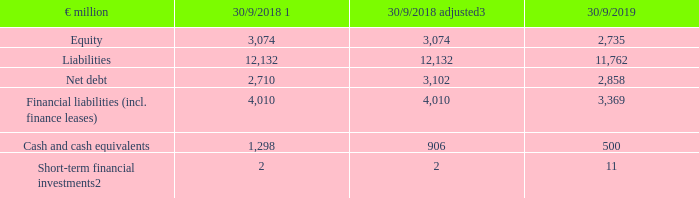Equity, liabilities and net debt in the consolidated financial statements
Equity amounts to €2,735 million (30/9/2018: €3,074 million), while liabilities amounts to €11,762 million (30/9/2018: €12,132 million). Net debt related to continuing operations decreased by €0.2 billion in the adjusted year-on-year comparison and amounted to €2.9 billion as of 30 September 2019 (30/09/2018: €3.1 billion).
1 Adjustment of previous year according to explanation in notes
2 Shown in the balance sheet under other financial assets (current).
3 Adjusted for the effects of discontinued operations.
What was the amount of equity in FY2019? €2,735 million. What was the amount of liabilities in FY2019? €11,762 million. What are the main components in the consolidated financial statements measured in the table? Equity, liabilities, net debt. In which year was the amount of Equity larger for FY2018 adjusted figures and FY2019 figures? 3,074>2,735
Answer: 2018. What was the change in equity in FY2019 from FY2018 adjusted?
Answer scale should be: million. 2,735-3,074
Answer: -339. What was the percentage change in equity in FY2019 from FY2018 adjusted?
Answer scale should be: percent. (2,735-3,074)/3,074
Answer: -11.03. 